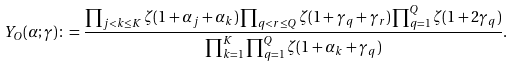Convert formula to latex. <formula><loc_0><loc_0><loc_500><loc_500>Y _ { O } ( \alpha ; \gamma ) \colon = \frac { \prod _ { j < k \leq K } \zeta ( 1 + \alpha _ { j } + \alpha _ { k } ) \prod _ { q < r \leq Q } \zeta ( 1 + \gamma _ { q } + \gamma _ { r } ) \prod _ { q = 1 } ^ { Q } \zeta ( 1 + 2 \gamma _ { q } ) } { \prod _ { k = 1 } ^ { K } \prod _ { q = 1 } ^ { Q } \zeta ( 1 + \alpha _ { k } + \gamma _ { q } ) } .</formula> 